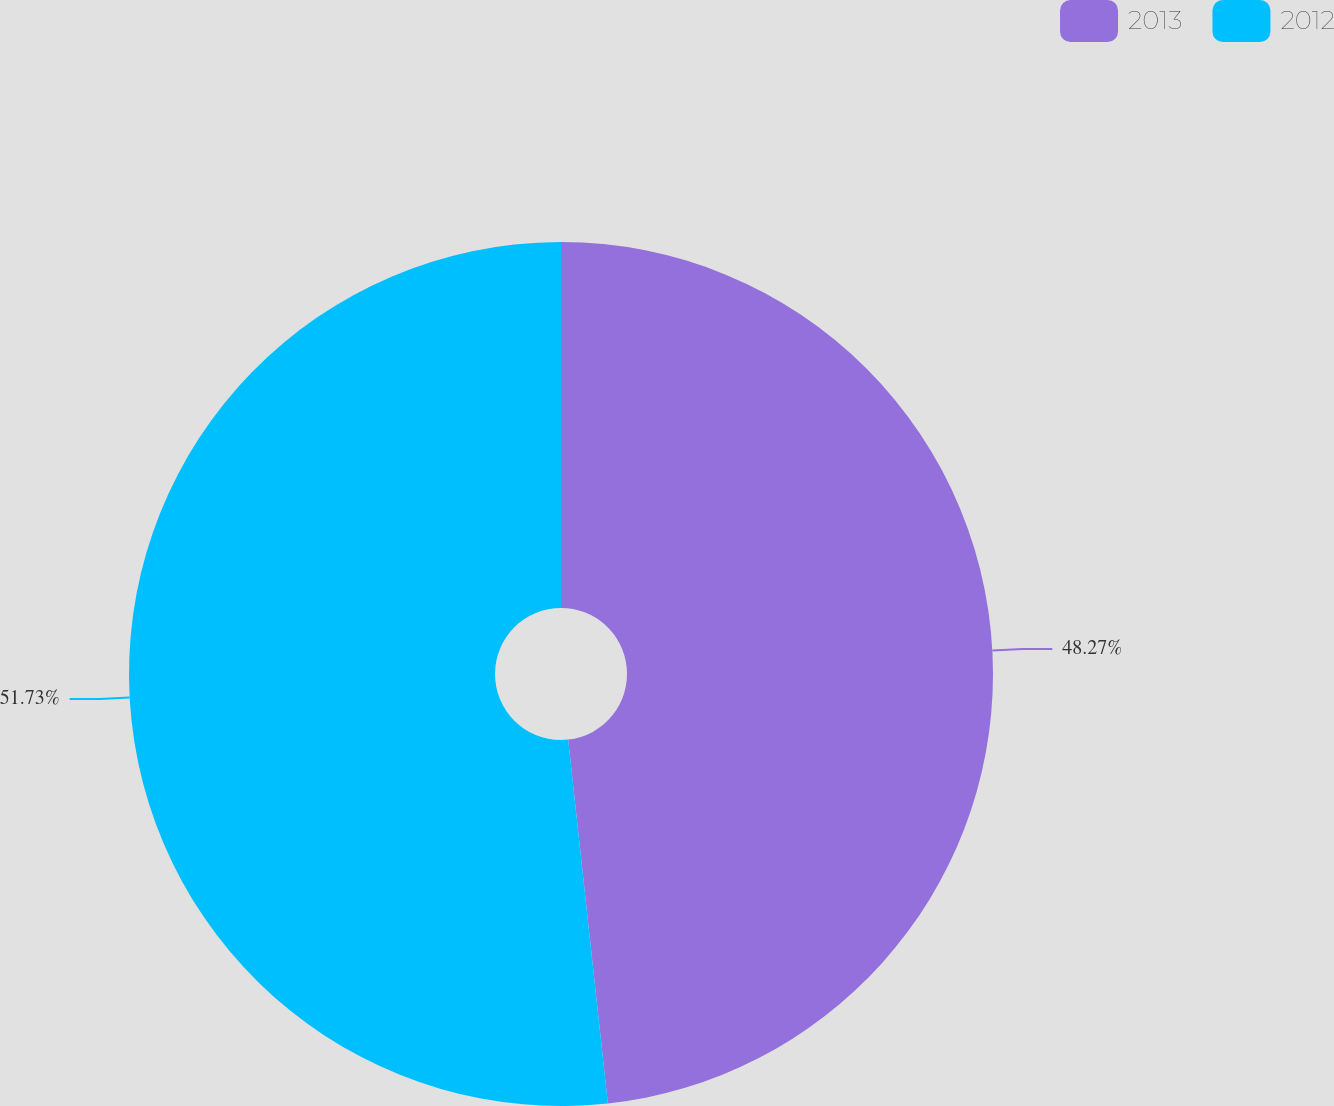<chart> <loc_0><loc_0><loc_500><loc_500><pie_chart><fcel>2013<fcel>2012<nl><fcel>48.27%<fcel>51.73%<nl></chart> 